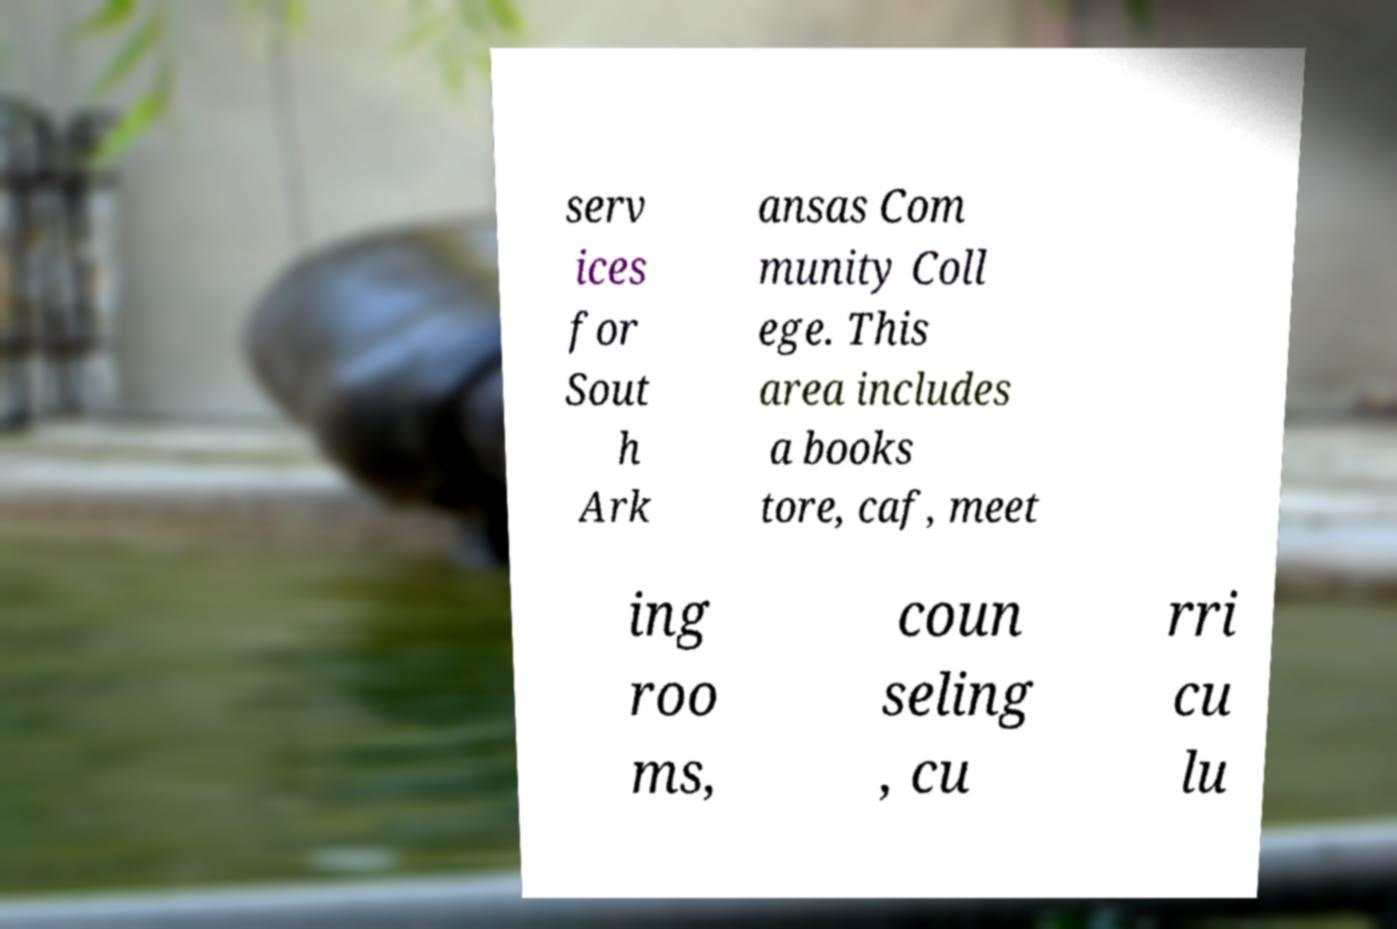Could you assist in decoding the text presented in this image and type it out clearly? serv ices for Sout h Ark ansas Com munity Coll ege. This area includes a books tore, caf, meet ing roo ms, coun seling , cu rri cu lu 